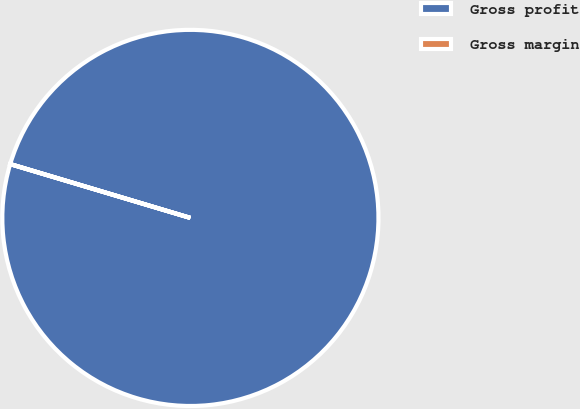Convert chart. <chart><loc_0><loc_0><loc_500><loc_500><pie_chart><fcel>Gross profit<fcel>Gross margin<nl><fcel>99.99%<fcel>0.01%<nl></chart> 